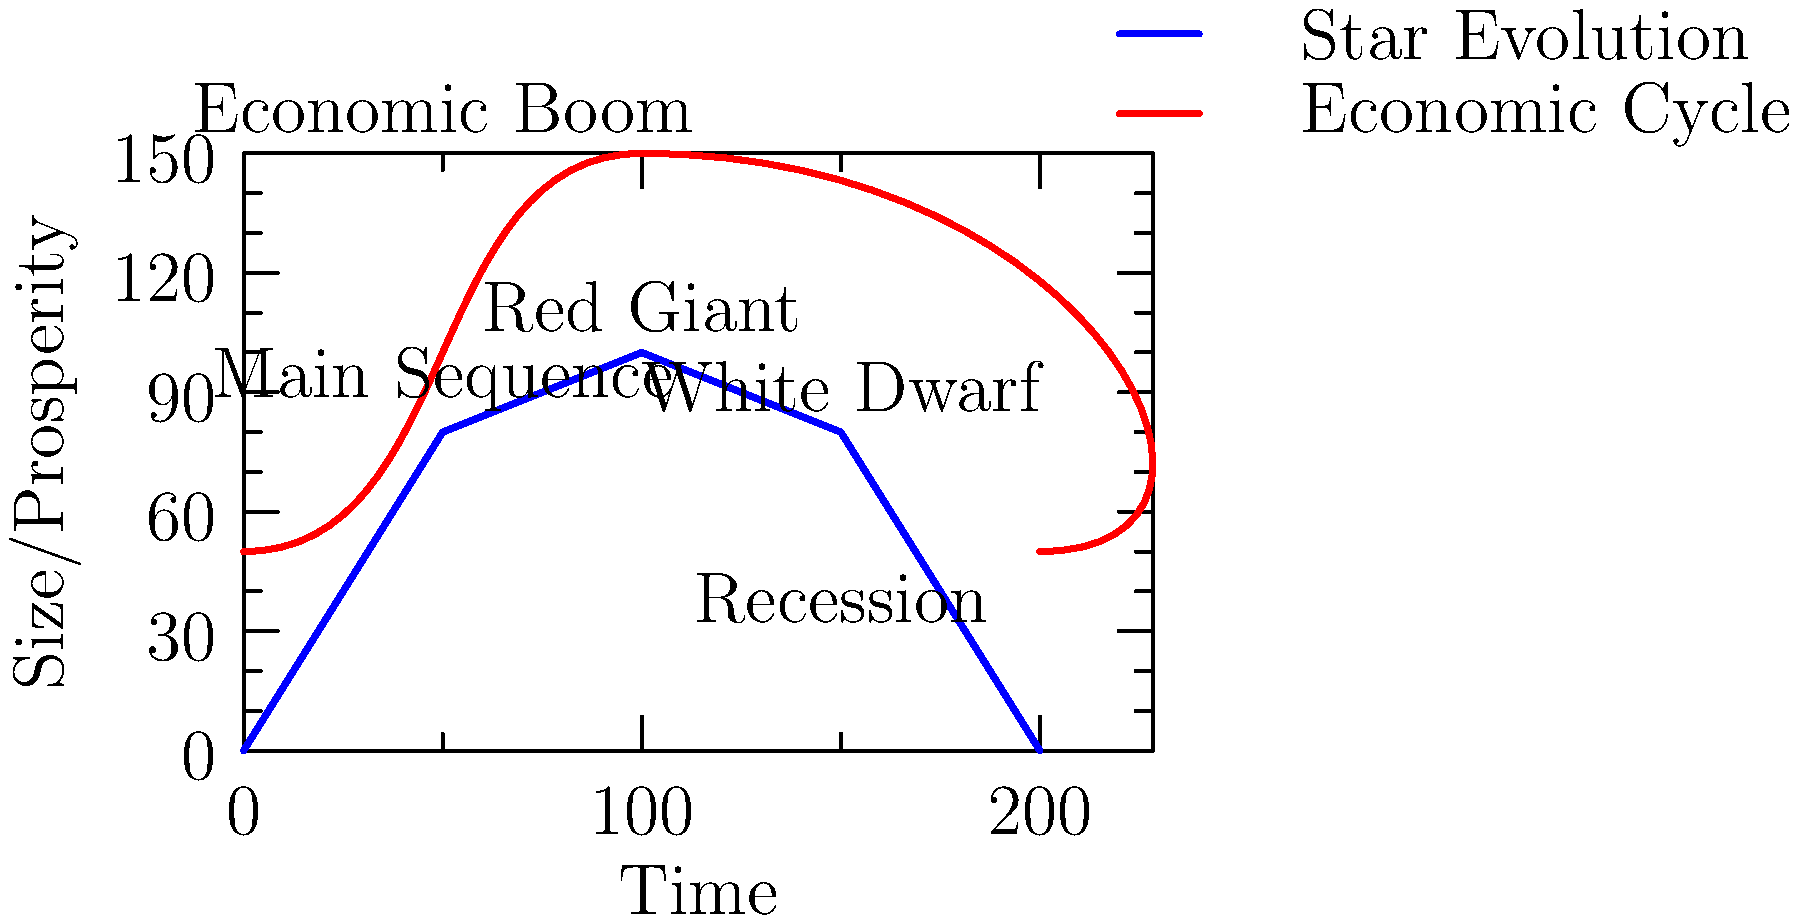In the diagram above, the blue line represents the life cycle of a star, while the red line represents economic cycles in a capitalist system. How do these cycles differ in terms of their long-term trajectories, and what implications might this have for the sustainability of each system? To answer this question, let's analyze the diagram step-by-step:

1. Star Evolution (Blue Line):
   - Starts at the Main Sequence stage
   - Expands to become a Red Giant
   - Contracts to a White Dwarf
   - Eventually ends at a low point (potential black dwarf)

2. Economic Cycle (Red Line):
   - Shows repetitive ups (booms) and downs (recessions)
   - Continues in a cyclical pattern without a defined endpoint

3. Key Differences:
   a) Trajectory:
      - Star evolution has a clear beginning and end
      - Economic cycle appears to repeat indefinitely

   b) Resource Usage:
      - Stars exhaust their fuel over time
      - Capitalist economies aim for continuous growth

   c) Sustainability:
      - Stars have a finite lifespan
      - Economic cycles suggest an assumption of infinite resources

4. Implications:
   a) Natural Limits:
      - Star evolution acknowledges natural limits
      - Economic cycles may ignore planetary boundaries

   b) Inequality:
      - Star evolution affects all matter within the star equally
      - Economic cycles may perpetuate and exacerbate inequality

   c) Long-term Viability:
      - Stars have a predictable end
      - The indefinite nature of economic cycles raises questions about long-term sustainability

5. Socialist Perspective:
   - The diagram suggests that capitalist systems, unlike stars, do not account for finite resources
   - This could lead to exploitation of both natural resources and labor
   - A socialist system might aim for a more sustainable, equitable distribution of resources

The comparison implies that while stellar evolution is a natural, finite process, capitalist economic cycles assume infinite growth, which may not be sustainable in a world with limited resources.
Answer: Star evolution acknowledges finite resources and natural limits, while capitalist economic cycles assume indefinite growth, potentially leading to unsustainable resource exploitation and perpetuating inequality. 